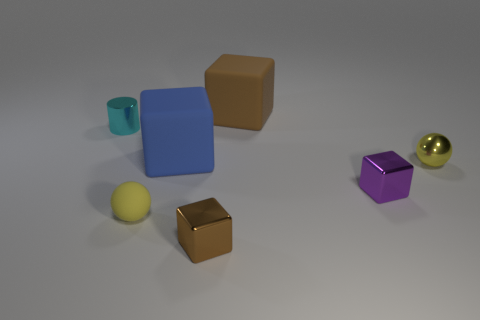Is there any other thing that is the same size as the purple shiny thing?
Your answer should be very brief. Yes. There is a brown matte cube; what number of metal cylinders are behind it?
Keep it short and to the point. 0. There is a big thing behind the cyan shiny thing; does it have the same color as the metallic object behind the large blue object?
Your answer should be compact. No. The other thing that is the same shape as the tiny rubber thing is what color?
Keep it short and to the point. Yellow. Is there anything else that has the same shape as the big blue thing?
Provide a succinct answer. Yes. There is a brown thing behind the tiny cyan shiny cylinder; does it have the same shape as the brown object that is in front of the tiny cyan metal cylinder?
Offer a terse response. Yes. There is a cyan cylinder; is its size the same as the brown object in front of the tiny purple thing?
Your answer should be compact. Yes. Is the number of big yellow cubes greater than the number of tiny purple metallic cubes?
Your response must be concise. No. Is the block behind the big blue matte thing made of the same material as the tiny sphere that is to the left of the yellow shiny sphere?
Offer a very short reply. Yes. What is the material of the big brown thing?
Your answer should be compact. Rubber. 